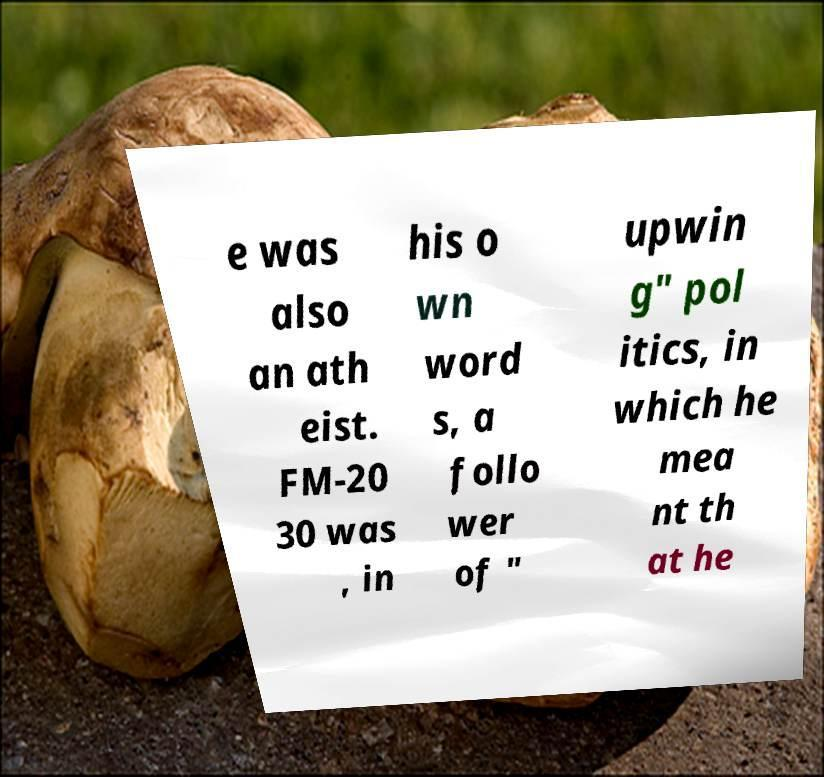What messages or text are displayed in this image? I need them in a readable, typed format. e was also an ath eist. FM-20 30 was , in his o wn word s, a follo wer of " upwin g" pol itics, in which he mea nt th at he 